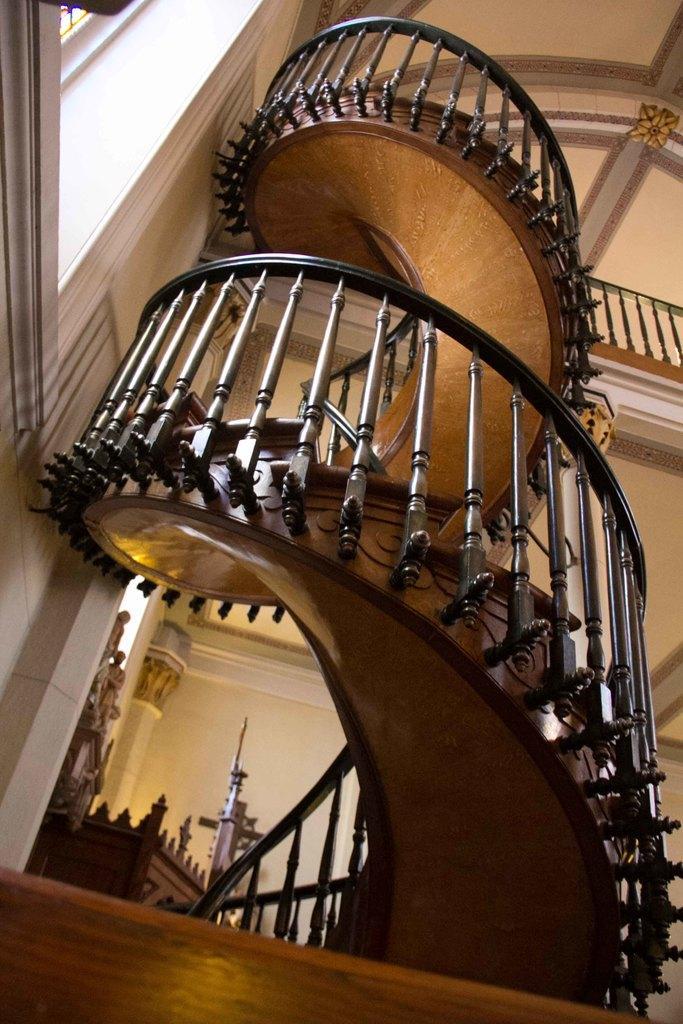Please provide a concise description of this image. In this image I can see the building which is cream in color and I can see the staircase, the railing and the brown colored surface. 